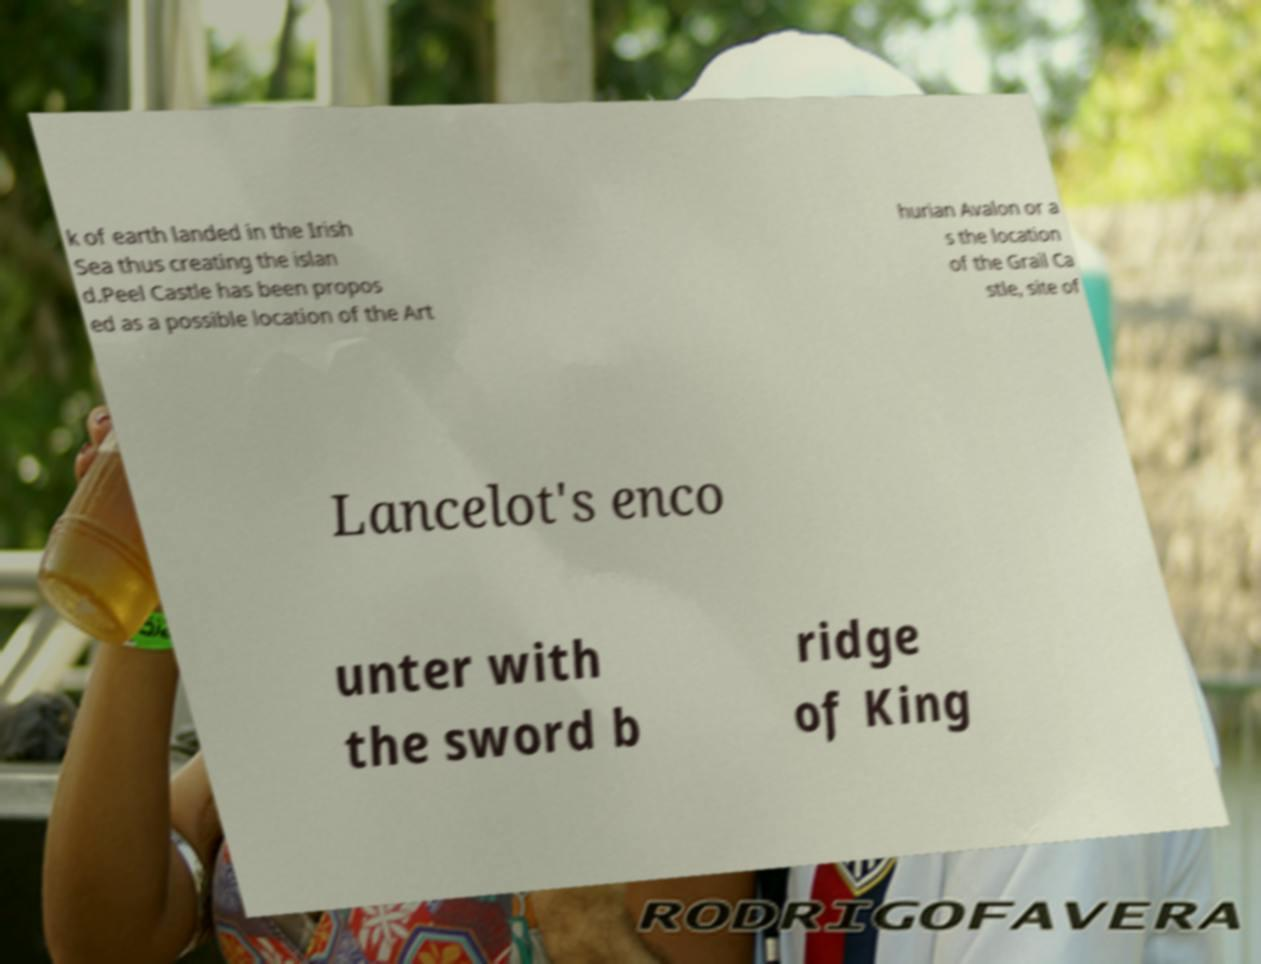Please identify and transcribe the text found in this image. k of earth landed in the Irish Sea thus creating the islan d.Peel Castle has been propos ed as a possible location of the Art hurian Avalon or a s the location of the Grail Ca stle, site of Lancelot's enco unter with the sword b ridge of King 